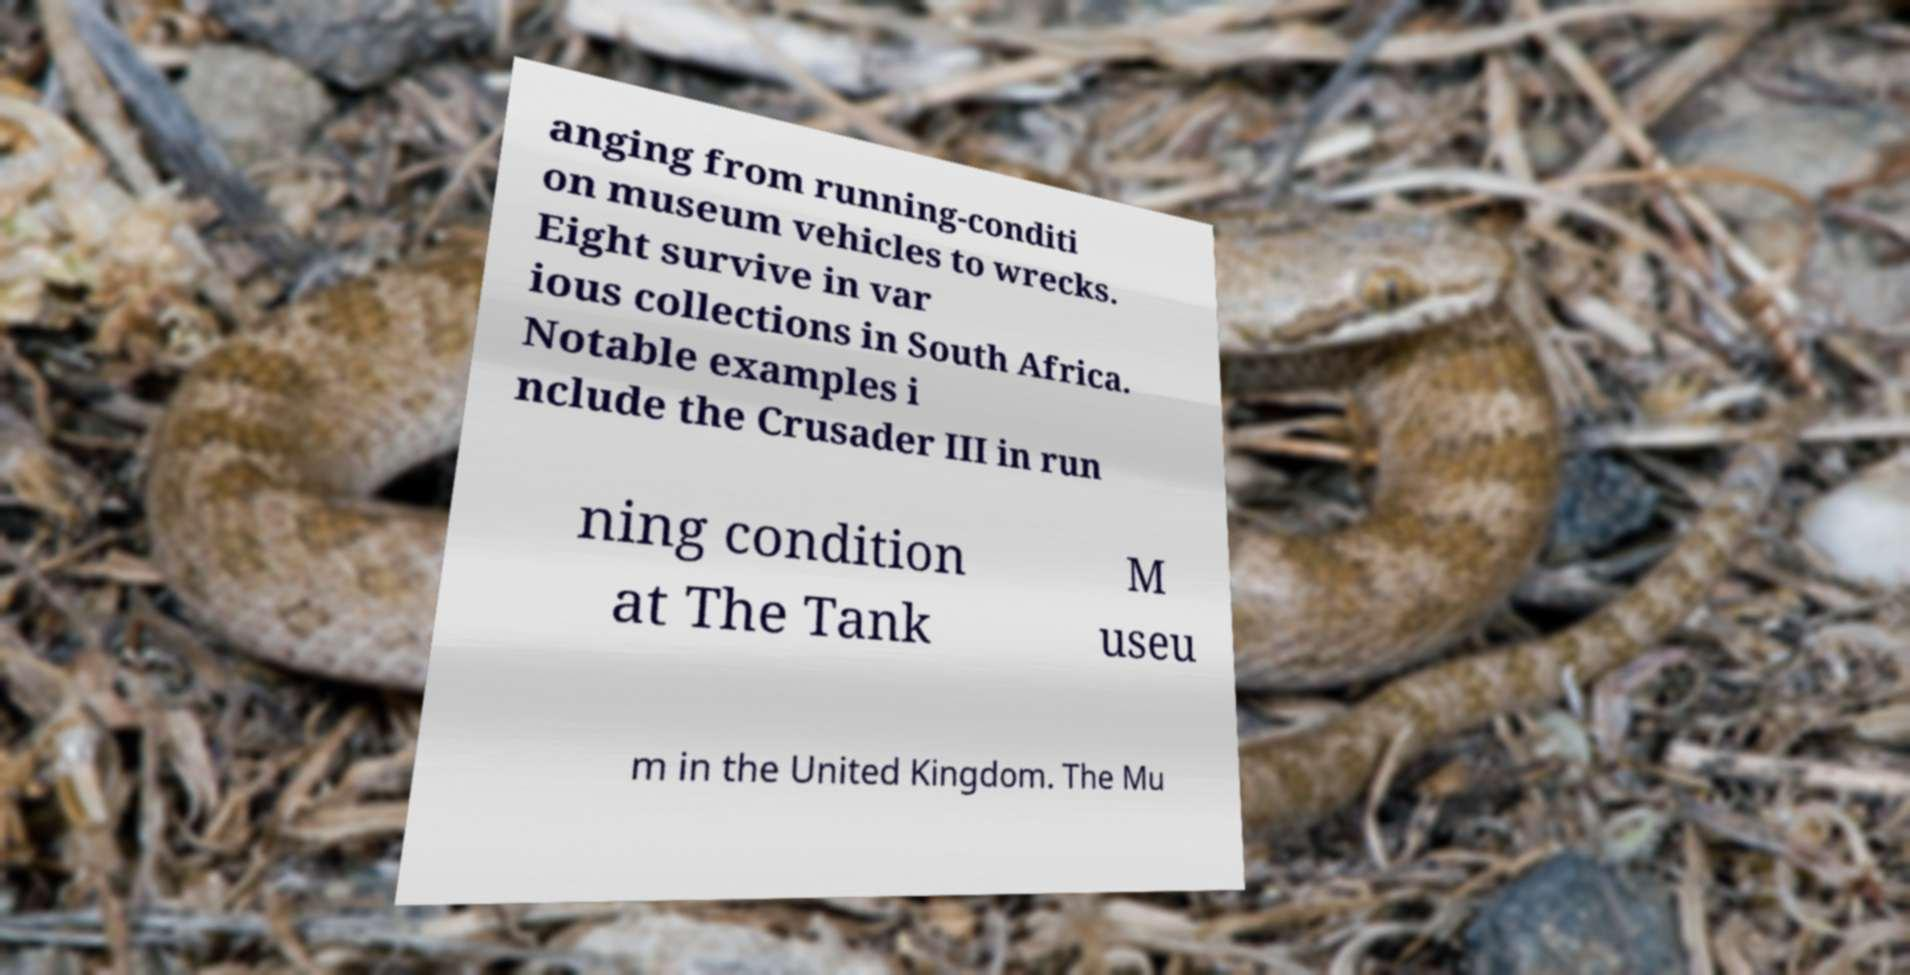For documentation purposes, I need the text within this image transcribed. Could you provide that? anging from running-conditi on museum vehicles to wrecks. Eight survive in var ious collections in South Africa. Notable examples i nclude the Crusader III in run ning condition at The Tank M useu m in the United Kingdom. The Mu 